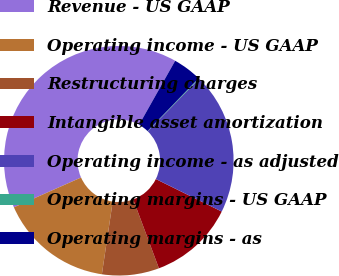Convert chart. <chart><loc_0><loc_0><loc_500><loc_500><pie_chart><fcel>Revenue - US GAAP<fcel>Operating income - US GAAP<fcel>Restructuring charges<fcel>Intangible asset amortization<fcel>Operating income - as adjusted<fcel>Operating margins - US GAAP<fcel>Operating margins - as<nl><fcel>39.82%<fcel>15.99%<fcel>8.04%<fcel>12.02%<fcel>19.96%<fcel>0.1%<fcel>4.07%<nl></chart> 